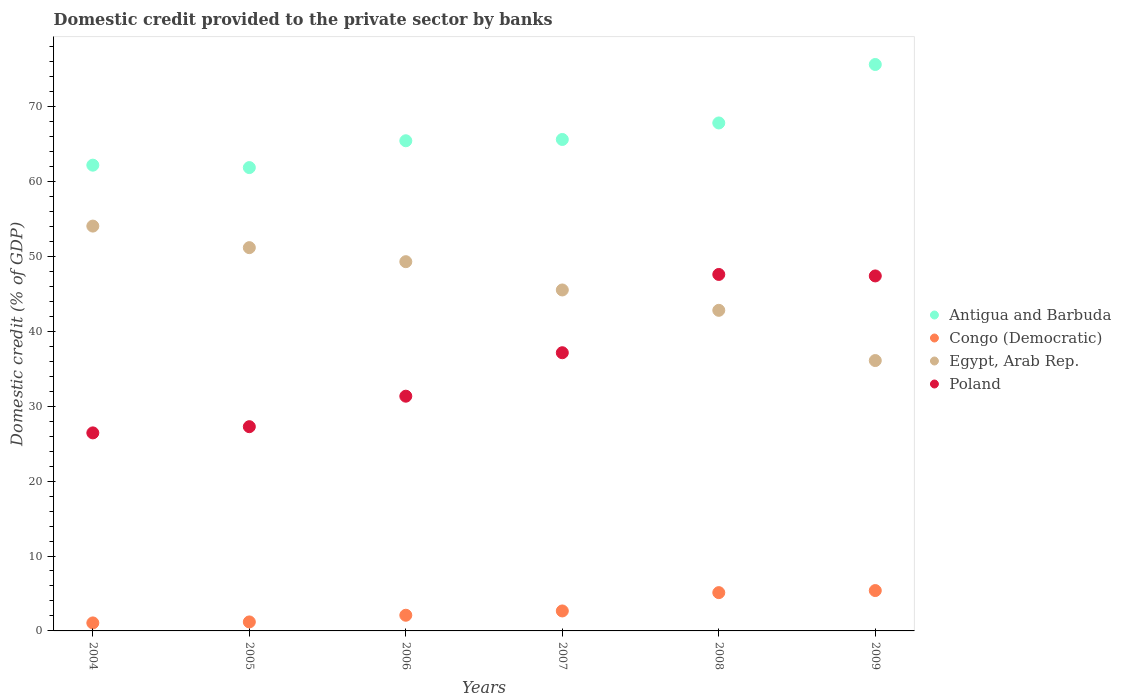How many different coloured dotlines are there?
Your answer should be compact. 4. What is the domestic credit provided to the private sector by banks in Congo (Democratic) in 2004?
Provide a succinct answer. 1.07. Across all years, what is the maximum domestic credit provided to the private sector by banks in Congo (Democratic)?
Offer a terse response. 5.39. Across all years, what is the minimum domestic credit provided to the private sector by banks in Congo (Democratic)?
Ensure brevity in your answer.  1.07. What is the total domestic credit provided to the private sector by banks in Poland in the graph?
Make the answer very short. 217.15. What is the difference between the domestic credit provided to the private sector by banks in Poland in 2005 and that in 2006?
Give a very brief answer. -4.07. What is the difference between the domestic credit provided to the private sector by banks in Antigua and Barbuda in 2006 and the domestic credit provided to the private sector by banks in Poland in 2004?
Ensure brevity in your answer.  39. What is the average domestic credit provided to the private sector by banks in Congo (Democratic) per year?
Offer a terse response. 2.92. In the year 2008, what is the difference between the domestic credit provided to the private sector by banks in Congo (Democratic) and domestic credit provided to the private sector by banks in Poland?
Ensure brevity in your answer.  -42.47. In how many years, is the domestic credit provided to the private sector by banks in Egypt, Arab Rep. greater than 4 %?
Provide a short and direct response. 6. What is the ratio of the domestic credit provided to the private sector by banks in Poland in 2006 to that in 2008?
Your answer should be compact. 0.66. Is the domestic credit provided to the private sector by banks in Antigua and Barbuda in 2006 less than that in 2009?
Offer a terse response. Yes. Is the difference between the domestic credit provided to the private sector by banks in Congo (Democratic) in 2005 and 2009 greater than the difference between the domestic credit provided to the private sector by banks in Poland in 2005 and 2009?
Give a very brief answer. Yes. What is the difference between the highest and the second highest domestic credit provided to the private sector by banks in Antigua and Barbuda?
Keep it short and to the point. 7.8. What is the difference between the highest and the lowest domestic credit provided to the private sector by banks in Congo (Democratic)?
Make the answer very short. 4.32. Is the sum of the domestic credit provided to the private sector by banks in Egypt, Arab Rep. in 2004 and 2007 greater than the maximum domestic credit provided to the private sector by banks in Poland across all years?
Make the answer very short. Yes. Is it the case that in every year, the sum of the domestic credit provided to the private sector by banks in Egypt, Arab Rep. and domestic credit provided to the private sector by banks in Poland  is greater than the sum of domestic credit provided to the private sector by banks in Antigua and Barbuda and domestic credit provided to the private sector by banks in Congo (Democratic)?
Ensure brevity in your answer.  Yes. Is it the case that in every year, the sum of the domestic credit provided to the private sector by banks in Congo (Democratic) and domestic credit provided to the private sector by banks in Egypt, Arab Rep.  is greater than the domestic credit provided to the private sector by banks in Poland?
Your response must be concise. No. Are the values on the major ticks of Y-axis written in scientific E-notation?
Offer a very short reply. No. Does the graph contain any zero values?
Your response must be concise. No. Does the graph contain grids?
Keep it short and to the point. No. How many legend labels are there?
Make the answer very short. 4. What is the title of the graph?
Your answer should be compact. Domestic credit provided to the private sector by banks. Does "Antigua and Barbuda" appear as one of the legend labels in the graph?
Give a very brief answer. Yes. What is the label or title of the Y-axis?
Provide a short and direct response. Domestic credit (% of GDP). What is the Domestic credit (% of GDP) of Antigua and Barbuda in 2004?
Your response must be concise. 62.18. What is the Domestic credit (% of GDP) of Congo (Democratic) in 2004?
Ensure brevity in your answer.  1.07. What is the Domestic credit (% of GDP) of Egypt, Arab Rep. in 2004?
Keep it short and to the point. 54.04. What is the Domestic credit (% of GDP) of Poland in 2004?
Your response must be concise. 26.44. What is the Domestic credit (% of GDP) in Antigua and Barbuda in 2005?
Your answer should be very brief. 61.85. What is the Domestic credit (% of GDP) in Congo (Democratic) in 2005?
Give a very brief answer. 1.2. What is the Domestic credit (% of GDP) of Egypt, Arab Rep. in 2005?
Provide a succinct answer. 51.17. What is the Domestic credit (% of GDP) in Poland in 2005?
Give a very brief answer. 27.27. What is the Domestic credit (% of GDP) of Antigua and Barbuda in 2006?
Ensure brevity in your answer.  65.43. What is the Domestic credit (% of GDP) in Congo (Democratic) in 2006?
Provide a short and direct response. 2.09. What is the Domestic credit (% of GDP) in Egypt, Arab Rep. in 2006?
Give a very brief answer. 49.29. What is the Domestic credit (% of GDP) in Poland in 2006?
Your answer should be very brief. 31.33. What is the Domestic credit (% of GDP) in Antigua and Barbuda in 2007?
Keep it short and to the point. 65.61. What is the Domestic credit (% of GDP) in Congo (Democratic) in 2007?
Make the answer very short. 2.67. What is the Domestic credit (% of GDP) in Egypt, Arab Rep. in 2007?
Provide a succinct answer. 45.52. What is the Domestic credit (% of GDP) of Poland in 2007?
Make the answer very short. 37.14. What is the Domestic credit (% of GDP) in Antigua and Barbuda in 2008?
Your answer should be compact. 67.81. What is the Domestic credit (% of GDP) in Congo (Democratic) in 2008?
Ensure brevity in your answer.  5.11. What is the Domestic credit (% of GDP) in Egypt, Arab Rep. in 2008?
Make the answer very short. 42.8. What is the Domestic credit (% of GDP) of Poland in 2008?
Offer a terse response. 47.59. What is the Domestic credit (% of GDP) in Antigua and Barbuda in 2009?
Offer a terse response. 75.61. What is the Domestic credit (% of GDP) in Congo (Democratic) in 2009?
Provide a short and direct response. 5.39. What is the Domestic credit (% of GDP) in Egypt, Arab Rep. in 2009?
Ensure brevity in your answer.  36.09. What is the Domestic credit (% of GDP) of Poland in 2009?
Provide a succinct answer. 47.39. Across all years, what is the maximum Domestic credit (% of GDP) in Antigua and Barbuda?
Your answer should be compact. 75.61. Across all years, what is the maximum Domestic credit (% of GDP) in Congo (Democratic)?
Your answer should be compact. 5.39. Across all years, what is the maximum Domestic credit (% of GDP) of Egypt, Arab Rep.?
Provide a short and direct response. 54.04. Across all years, what is the maximum Domestic credit (% of GDP) in Poland?
Your response must be concise. 47.59. Across all years, what is the minimum Domestic credit (% of GDP) in Antigua and Barbuda?
Ensure brevity in your answer.  61.85. Across all years, what is the minimum Domestic credit (% of GDP) in Congo (Democratic)?
Give a very brief answer. 1.07. Across all years, what is the minimum Domestic credit (% of GDP) in Egypt, Arab Rep.?
Ensure brevity in your answer.  36.09. Across all years, what is the minimum Domestic credit (% of GDP) of Poland?
Offer a terse response. 26.44. What is the total Domestic credit (% of GDP) in Antigua and Barbuda in the graph?
Keep it short and to the point. 398.49. What is the total Domestic credit (% of GDP) of Congo (Democratic) in the graph?
Your answer should be compact. 17.53. What is the total Domestic credit (% of GDP) in Egypt, Arab Rep. in the graph?
Make the answer very short. 278.9. What is the total Domestic credit (% of GDP) of Poland in the graph?
Make the answer very short. 217.15. What is the difference between the Domestic credit (% of GDP) of Antigua and Barbuda in 2004 and that in 2005?
Give a very brief answer. 0.32. What is the difference between the Domestic credit (% of GDP) of Congo (Democratic) in 2004 and that in 2005?
Provide a short and direct response. -0.13. What is the difference between the Domestic credit (% of GDP) of Egypt, Arab Rep. in 2004 and that in 2005?
Your response must be concise. 2.88. What is the difference between the Domestic credit (% of GDP) of Poland in 2004 and that in 2005?
Ensure brevity in your answer.  -0.83. What is the difference between the Domestic credit (% of GDP) in Antigua and Barbuda in 2004 and that in 2006?
Offer a very short reply. -3.26. What is the difference between the Domestic credit (% of GDP) of Congo (Democratic) in 2004 and that in 2006?
Provide a short and direct response. -1.02. What is the difference between the Domestic credit (% of GDP) of Egypt, Arab Rep. in 2004 and that in 2006?
Give a very brief answer. 4.75. What is the difference between the Domestic credit (% of GDP) of Poland in 2004 and that in 2006?
Your response must be concise. -4.9. What is the difference between the Domestic credit (% of GDP) in Antigua and Barbuda in 2004 and that in 2007?
Ensure brevity in your answer.  -3.43. What is the difference between the Domestic credit (% of GDP) of Congo (Democratic) in 2004 and that in 2007?
Make the answer very short. -1.6. What is the difference between the Domestic credit (% of GDP) of Egypt, Arab Rep. in 2004 and that in 2007?
Your response must be concise. 8.53. What is the difference between the Domestic credit (% of GDP) in Poland in 2004 and that in 2007?
Offer a terse response. -10.7. What is the difference between the Domestic credit (% of GDP) of Antigua and Barbuda in 2004 and that in 2008?
Your response must be concise. -5.63. What is the difference between the Domestic credit (% of GDP) in Congo (Democratic) in 2004 and that in 2008?
Offer a terse response. -4.04. What is the difference between the Domestic credit (% of GDP) of Egypt, Arab Rep. in 2004 and that in 2008?
Provide a succinct answer. 11.25. What is the difference between the Domestic credit (% of GDP) of Poland in 2004 and that in 2008?
Offer a terse response. -21.15. What is the difference between the Domestic credit (% of GDP) of Antigua and Barbuda in 2004 and that in 2009?
Your answer should be very brief. -13.44. What is the difference between the Domestic credit (% of GDP) in Congo (Democratic) in 2004 and that in 2009?
Your answer should be compact. -4.32. What is the difference between the Domestic credit (% of GDP) in Egypt, Arab Rep. in 2004 and that in 2009?
Offer a terse response. 17.95. What is the difference between the Domestic credit (% of GDP) in Poland in 2004 and that in 2009?
Provide a succinct answer. -20.95. What is the difference between the Domestic credit (% of GDP) of Antigua and Barbuda in 2005 and that in 2006?
Your response must be concise. -3.58. What is the difference between the Domestic credit (% of GDP) of Congo (Democratic) in 2005 and that in 2006?
Offer a terse response. -0.89. What is the difference between the Domestic credit (% of GDP) of Egypt, Arab Rep. in 2005 and that in 2006?
Offer a very short reply. 1.87. What is the difference between the Domestic credit (% of GDP) of Poland in 2005 and that in 2006?
Provide a succinct answer. -4.07. What is the difference between the Domestic credit (% of GDP) in Antigua and Barbuda in 2005 and that in 2007?
Make the answer very short. -3.75. What is the difference between the Domestic credit (% of GDP) in Congo (Democratic) in 2005 and that in 2007?
Give a very brief answer. -1.46. What is the difference between the Domestic credit (% of GDP) of Egypt, Arab Rep. in 2005 and that in 2007?
Make the answer very short. 5.65. What is the difference between the Domestic credit (% of GDP) in Poland in 2005 and that in 2007?
Give a very brief answer. -9.87. What is the difference between the Domestic credit (% of GDP) in Antigua and Barbuda in 2005 and that in 2008?
Your answer should be very brief. -5.96. What is the difference between the Domestic credit (% of GDP) of Congo (Democratic) in 2005 and that in 2008?
Keep it short and to the point. -3.91. What is the difference between the Domestic credit (% of GDP) in Egypt, Arab Rep. in 2005 and that in 2008?
Provide a short and direct response. 8.37. What is the difference between the Domestic credit (% of GDP) in Poland in 2005 and that in 2008?
Offer a terse response. -20.32. What is the difference between the Domestic credit (% of GDP) of Antigua and Barbuda in 2005 and that in 2009?
Offer a very short reply. -13.76. What is the difference between the Domestic credit (% of GDP) in Congo (Democratic) in 2005 and that in 2009?
Provide a succinct answer. -4.19. What is the difference between the Domestic credit (% of GDP) of Egypt, Arab Rep. in 2005 and that in 2009?
Keep it short and to the point. 15.07. What is the difference between the Domestic credit (% of GDP) of Poland in 2005 and that in 2009?
Provide a succinct answer. -20.12. What is the difference between the Domestic credit (% of GDP) in Antigua and Barbuda in 2006 and that in 2007?
Your answer should be compact. -0.17. What is the difference between the Domestic credit (% of GDP) of Congo (Democratic) in 2006 and that in 2007?
Ensure brevity in your answer.  -0.57. What is the difference between the Domestic credit (% of GDP) of Egypt, Arab Rep. in 2006 and that in 2007?
Offer a terse response. 3.78. What is the difference between the Domestic credit (% of GDP) of Poland in 2006 and that in 2007?
Give a very brief answer. -5.8. What is the difference between the Domestic credit (% of GDP) of Antigua and Barbuda in 2006 and that in 2008?
Your answer should be compact. -2.38. What is the difference between the Domestic credit (% of GDP) of Congo (Democratic) in 2006 and that in 2008?
Ensure brevity in your answer.  -3.02. What is the difference between the Domestic credit (% of GDP) of Egypt, Arab Rep. in 2006 and that in 2008?
Offer a terse response. 6.49. What is the difference between the Domestic credit (% of GDP) of Poland in 2006 and that in 2008?
Your answer should be compact. -16.25. What is the difference between the Domestic credit (% of GDP) of Antigua and Barbuda in 2006 and that in 2009?
Keep it short and to the point. -10.18. What is the difference between the Domestic credit (% of GDP) of Congo (Democratic) in 2006 and that in 2009?
Provide a short and direct response. -3.3. What is the difference between the Domestic credit (% of GDP) in Egypt, Arab Rep. in 2006 and that in 2009?
Make the answer very short. 13.2. What is the difference between the Domestic credit (% of GDP) of Poland in 2006 and that in 2009?
Your response must be concise. -16.05. What is the difference between the Domestic credit (% of GDP) in Antigua and Barbuda in 2007 and that in 2008?
Ensure brevity in your answer.  -2.2. What is the difference between the Domestic credit (% of GDP) of Congo (Democratic) in 2007 and that in 2008?
Make the answer very short. -2.45. What is the difference between the Domestic credit (% of GDP) of Egypt, Arab Rep. in 2007 and that in 2008?
Offer a terse response. 2.72. What is the difference between the Domestic credit (% of GDP) of Poland in 2007 and that in 2008?
Offer a terse response. -10.45. What is the difference between the Domestic credit (% of GDP) of Antigua and Barbuda in 2007 and that in 2009?
Offer a terse response. -10.01. What is the difference between the Domestic credit (% of GDP) in Congo (Democratic) in 2007 and that in 2009?
Ensure brevity in your answer.  -2.72. What is the difference between the Domestic credit (% of GDP) in Egypt, Arab Rep. in 2007 and that in 2009?
Offer a very short reply. 9.42. What is the difference between the Domestic credit (% of GDP) in Poland in 2007 and that in 2009?
Offer a very short reply. -10.25. What is the difference between the Domestic credit (% of GDP) in Antigua and Barbuda in 2008 and that in 2009?
Provide a short and direct response. -7.8. What is the difference between the Domestic credit (% of GDP) of Congo (Democratic) in 2008 and that in 2009?
Ensure brevity in your answer.  -0.28. What is the difference between the Domestic credit (% of GDP) in Egypt, Arab Rep. in 2008 and that in 2009?
Provide a succinct answer. 6.7. What is the difference between the Domestic credit (% of GDP) of Poland in 2008 and that in 2009?
Offer a very short reply. 0.2. What is the difference between the Domestic credit (% of GDP) in Antigua and Barbuda in 2004 and the Domestic credit (% of GDP) in Congo (Democratic) in 2005?
Keep it short and to the point. 60.97. What is the difference between the Domestic credit (% of GDP) in Antigua and Barbuda in 2004 and the Domestic credit (% of GDP) in Egypt, Arab Rep. in 2005?
Give a very brief answer. 11.01. What is the difference between the Domestic credit (% of GDP) in Antigua and Barbuda in 2004 and the Domestic credit (% of GDP) in Poland in 2005?
Keep it short and to the point. 34.91. What is the difference between the Domestic credit (% of GDP) in Congo (Democratic) in 2004 and the Domestic credit (% of GDP) in Egypt, Arab Rep. in 2005?
Give a very brief answer. -50.1. What is the difference between the Domestic credit (% of GDP) in Congo (Democratic) in 2004 and the Domestic credit (% of GDP) in Poland in 2005?
Ensure brevity in your answer.  -26.2. What is the difference between the Domestic credit (% of GDP) in Egypt, Arab Rep. in 2004 and the Domestic credit (% of GDP) in Poland in 2005?
Your answer should be very brief. 26.78. What is the difference between the Domestic credit (% of GDP) in Antigua and Barbuda in 2004 and the Domestic credit (% of GDP) in Congo (Democratic) in 2006?
Your response must be concise. 60.08. What is the difference between the Domestic credit (% of GDP) in Antigua and Barbuda in 2004 and the Domestic credit (% of GDP) in Egypt, Arab Rep. in 2006?
Your answer should be compact. 12.88. What is the difference between the Domestic credit (% of GDP) in Antigua and Barbuda in 2004 and the Domestic credit (% of GDP) in Poland in 2006?
Offer a terse response. 30.84. What is the difference between the Domestic credit (% of GDP) of Congo (Democratic) in 2004 and the Domestic credit (% of GDP) of Egypt, Arab Rep. in 2006?
Keep it short and to the point. -48.22. What is the difference between the Domestic credit (% of GDP) in Congo (Democratic) in 2004 and the Domestic credit (% of GDP) in Poland in 2006?
Your answer should be very brief. -30.27. What is the difference between the Domestic credit (% of GDP) in Egypt, Arab Rep. in 2004 and the Domestic credit (% of GDP) in Poland in 2006?
Keep it short and to the point. 22.71. What is the difference between the Domestic credit (% of GDP) in Antigua and Barbuda in 2004 and the Domestic credit (% of GDP) in Congo (Democratic) in 2007?
Provide a short and direct response. 59.51. What is the difference between the Domestic credit (% of GDP) of Antigua and Barbuda in 2004 and the Domestic credit (% of GDP) of Egypt, Arab Rep. in 2007?
Your response must be concise. 16.66. What is the difference between the Domestic credit (% of GDP) of Antigua and Barbuda in 2004 and the Domestic credit (% of GDP) of Poland in 2007?
Give a very brief answer. 25.04. What is the difference between the Domestic credit (% of GDP) of Congo (Democratic) in 2004 and the Domestic credit (% of GDP) of Egypt, Arab Rep. in 2007?
Give a very brief answer. -44.45. What is the difference between the Domestic credit (% of GDP) in Congo (Democratic) in 2004 and the Domestic credit (% of GDP) in Poland in 2007?
Your answer should be compact. -36.07. What is the difference between the Domestic credit (% of GDP) of Egypt, Arab Rep. in 2004 and the Domestic credit (% of GDP) of Poland in 2007?
Make the answer very short. 16.91. What is the difference between the Domestic credit (% of GDP) in Antigua and Barbuda in 2004 and the Domestic credit (% of GDP) in Congo (Democratic) in 2008?
Ensure brevity in your answer.  57.06. What is the difference between the Domestic credit (% of GDP) in Antigua and Barbuda in 2004 and the Domestic credit (% of GDP) in Egypt, Arab Rep. in 2008?
Your response must be concise. 19.38. What is the difference between the Domestic credit (% of GDP) of Antigua and Barbuda in 2004 and the Domestic credit (% of GDP) of Poland in 2008?
Your answer should be compact. 14.59. What is the difference between the Domestic credit (% of GDP) of Congo (Democratic) in 2004 and the Domestic credit (% of GDP) of Egypt, Arab Rep. in 2008?
Ensure brevity in your answer.  -41.73. What is the difference between the Domestic credit (% of GDP) of Congo (Democratic) in 2004 and the Domestic credit (% of GDP) of Poland in 2008?
Your response must be concise. -46.52. What is the difference between the Domestic credit (% of GDP) in Egypt, Arab Rep. in 2004 and the Domestic credit (% of GDP) in Poland in 2008?
Ensure brevity in your answer.  6.46. What is the difference between the Domestic credit (% of GDP) in Antigua and Barbuda in 2004 and the Domestic credit (% of GDP) in Congo (Democratic) in 2009?
Offer a terse response. 56.79. What is the difference between the Domestic credit (% of GDP) of Antigua and Barbuda in 2004 and the Domestic credit (% of GDP) of Egypt, Arab Rep. in 2009?
Offer a terse response. 26.08. What is the difference between the Domestic credit (% of GDP) of Antigua and Barbuda in 2004 and the Domestic credit (% of GDP) of Poland in 2009?
Your answer should be compact. 14.79. What is the difference between the Domestic credit (% of GDP) in Congo (Democratic) in 2004 and the Domestic credit (% of GDP) in Egypt, Arab Rep. in 2009?
Provide a succinct answer. -35.02. What is the difference between the Domestic credit (% of GDP) of Congo (Democratic) in 2004 and the Domestic credit (% of GDP) of Poland in 2009?
Your answer should be very brief. -46.32. What is the difference between the Domestic credit (% of GDP) in Egypt, Arab Rep. in 2004 and the Domestic credit (% of GDP) in Poland in 2009?
Keep it short and to the point. 6.65. What is the difference between the Domestic credit (% of GDP) of Antigua and Barbuda in 2005 and the Domestic credit (% of GDP) of Congo (Democratic) in 2006?
Your answer should be compact. 59.76. What is the difference between the Domestic credit (% of GDP) in Antigua and Barbuda in 2005 and the Domestic credit (% of GDP) in Egypt, Arab Rep. in 2006?
Keep it short and to the point. 12.56. What is the difference between the Domestic credit (% of GDP) in Antigua and Barbuda in 2005 and the Domestic credit (% of GDP) in Poland in 2006?
Your response must be concise. 30.52. What is the difference between the Domestic credit (% of GDP) in Congo (Democratic) in 2005 and the Domestic credit (% of GDP) in Egypt, Arab Rep. in 2006?
Provide a short and direct response. -48.09. What is the difference between the Domestic credit (% of GDP) in Congo (Democratic) in 2005 and the Domestic credit (% of GDP) in Poland in 2006?
Provide a short and direct response. -30.13. What is the difference between the Domestic credit (% of GDP) of Egypt, Arab Rep. in 2005 and the Domestic credit (% of GDP) of Poland in 2006?
Ensure brevity in your answer.  19.83. What is the difference between the Domestic credit (% of GDP) in Antigua and Barbuda in 2005 and the Domestic credit (% of GDP) in Congo (Democratic) in 2007?
Ensure brevity in your answer.  59.19. What is the difference between the Domestic credit (% of GDP) of Antigua and Barbuda in 2005 and the Domestic credit (% of GDP) of Egypt, Arab Rep. in 2007?
Offer a very short reply. 16.34. What is the difference between the Domestic credit (% of GDP) in Antigua and Barbuda in 2005 and the Domestic credit (% of GDP) in Poland in 2007?
Offer a terse response. 24.72. What is the difference between the Domestic credit (% of GDP) in Congo (Democratic) in 2005 and the Domestic credit (% of GDP) in Egypt, Arab Rep. in 2007?
Make the answer very short. -44.31. What is the difference between the Domestic credit (% of GDP) of Congo (Democratic) in 2005 and the Domestic credit (% of GDP) of Poland in 2007?
Your answer should be compact. -35.94. What is the difference between the Domestic credit (% of GDP) of Egypt, Arab Rep. in 2005 and the Domestic credit (% of GDP) of Poland in 2007?
Make the answer very short. 14.03. What is the difference between the Domestic credit (% of GDP) of Antigua and Barbuda in 2005 and the Domestic credit (% of GDP) of Congo (Democratic) in 2008?
Your answer should be compact. 56.74. What is the difference between the Domestic credit (% of GDP) in Antigua and Barbuda in 2005 and the Domestic credit (% of GDP) in Egypt, Arab Rep. in 2008?
Make the answer very short. 19.06. What is the difference between the Domestic credit (% of GDP) in Antigua and Barbuda in 2005 and the Domestic credit (% of GDP) in Poland in 2008?
Your answer should be compact. 14.27. What is the difference between the Domestic credit (% of GDP) of Congo (Democratic) in 2005 and the Domestic credit (% of GDP) of Egypt, Arab Rep. in 2008?
Offer a terse response. -41.6. What is the difference between the Domestic credit (% of GDP) of Congo (Democratic) in 2005 and the Domestic credit (% of GDP) of Poland in 2008?
Give a very brief answer. -46.39. What is the difference between the Domestic credit (% of GDP) of Egypt, Arab Rep. in 2005 and the Domestic credit (% of GDP) of Poland in 2008?
Offer a very short reply. 3.58. What is the difference between the Domestic credit (% of GDP) in Antigua and Barbuda in 2005 and the Domestic credit (% of GDP) in Congo (Democratic) in 2009?
Offer a terse response. 56.47. What is the difference between the Domestic credit (% of GDP) in Antigua and Barbuda in 2005 and the Domestic credit (% of GDP) in Egypt, Arab Rep. in 2009?
Provide a succinct answer. 25.76. What is the difference between the Domestic credit (% of GDP) of Antigua and Barbuda in 2005 and the Domestic credit (% of GDP) of Poland in 2009?
Keep it short and to the point. 14.46. What is the difference between the Domestic credit (% of GDP) of Congo (Democratic) in 2005 and the Domestic credit (% of GDP) of Egypt, Arab Rep. in 2009?
Your response must be concise. -34.89. What is the difference between the Domestic credit (% of GDP) of Congo (Democratic) in 2005 and the Domestic credit (% of GDP) of Poland in 2009?
Ensure brevity in your answer.  -46.19. What is the difference between the Domestic credit (% of GDP) in Egypt, Arab Rep. in 2005 and the Domestic credit (% of GDP) in Poland in 2009?
Make the answer very short. 3.78. What is the difference between the Domestic credit (% of GDP) of Antigua and Barbuda in 2006 and the Domestic credit (% of GDP) of Congo (Democratic) in 2007?
Offer a very short reply. 62.77. What is the difference between the Domestic credit (% of GDP) of Antigua and Barbuda in 2006 and the Domestic credit (% of GDP) of Egypt, Arab Rep. in 2007?
Provide a short and direct response. 19.92. What is the difference between the Domestic credit (% of GDP) in Antigua and Barbuda in 2006 and the Domestic credit (% of GDP) in Poland in 2007?
Your response must be concise. 28.3. What is the difference between the Domestic credit (% of GDP) of Congo (Democratic) in 2006 and the Domestic credit (% of GDP) of Egypt, Arab Rep. in 2007?
Ensure brevity in your answer.  -43.42. What is the difference between the Domestic credit (% of GDP) in Congo (Democratic) in 2006 and the Domestic credit (% of GDP) in Poland in 2007?
Give a very brief answer. -35.05. What is the difference between the Domestic credit (% of GDP) in Egypt, Arab Rep. in 2006 and the Domestic credit (% of GDP) in Poland in 2007?
Your answer should be compact. 12.15. What is the difference between the Domestic credit (% of GDP) in Antigua and Barbuda in 2006 and the Domestic credit (% of GDP) in Congo (Democratic) in 2008?
Make the answer very short. 60.32. What is the difference between the Domestic credit (% of GDP) of Antigua and Barbuda in 2006 and the Domestic credit (% of GDP) of Egypt, Arab Rep. in 2008?
Provide a short and direct response. 22.64. What is the difference between the Domestic credit (% of GDP) of Antigua and Barbuda in 2006 and the Domestic credit (% of GDP) of Poland in 2008?
Provide a succinct answer. 17.85. What is the difference between the Domestic credit (% of GDP) of Congo (Democratic) in 2006 and the Domestic credit (% of GDP) of Egypt, Arab Rep. in 2008?
Give a very brief answer. -40.71. What is the difference between the Domestic credit (% of GDP) of Congo (Democratic) in 2006 and the Domestic credit (% of GDP) of Poland in 2008?
Your answer should be compact. -45.49. What is the difference between the Domestic credit (% of GDP) in Egypt, Arab Rep. in 2006 and the Domestic credit (% of GDP) in Poland in 2008?
Give a very brief answer. 1.7. What is the difference between the Domestic credit (% of GDP) of Antigua and Barbuda in 2006 and the Domestic credit (% of GDP) of Congo (Democratic) in 2009?
Your answer should be very brief. 60.05. What is the difference between the Domestic credit (% of GDP) in Antigua and Barbuda in 2006 and the Domestic credit (% of GDP) in Egypt, Arab Rep. in 2009?
Your answer should be very brief. 29.34. What is the difference between the Domestic credit (% of GDP) of Antigua and Barbuda in 2006 and the Domestic credit (% of GDP) of Poland in 2009?
Give a very brief answer. 18.05. What is the difference between the Domestic credit (% of GDP) in Congo (Democratic) in 2006 and the Domestic credit (% of GDP) in Egypt, Arab Rep. in 2009?
Keep it short and to the point. -34. What is the difference between the Domestic credit (% of GDP) of Congo (Democratic) in 2006 and the Domestic credit (% of GDP) of Poland in 2009?
Provide a succinct answer. -45.3. What is the difference between the Domestic credit (% of GDP) in Egypt, Arab Rep. in 2006 and the Domestic credit (% of GDP) in Poland in 2009?
Provide a short and direct response. 1.9. What is the difference between the Domestic credit (% of GDP) of Antigua and Barbuda in 2007 and the Domestic credit (% of GDP) of Congo (Democratic) in 2008?
Keep it short and to the point. 60.49. What is the difference between the Domestic credit (% of GDP) of Antigua and Barbuda in 2007 and the Domestic credit (% of GDP) of Egypt, Arab Rep. in 2008?
Ensure brevity in your answer.  22.81. What is the difference between the Domestic credit (% of GDP) of Antigua and Barbuda in 2007 and the Domestic credit (% of GDP) of Poland in 2008?
Your answer should be compact. 18.02. What is the difference between the Domestic credit (% of GDP) of Congo (Democratic) in 2007 and the Domestic credit (% of GDP) of Egypt, Arab Rep. in 2008?
Your answer should be very brief. -40.13. What is the difference between the Domestic credit (% of GDP) in Congo (Democratic) in 2007 and the Domestic credit (% of GDP) in Poland in 2008?
Your answer should be compact. -44.92. What is the difference between the Domestic credit (% of GDP) in Egypt, Arab Rep. in 2007 and the Domestic credit (% of GDP) in Poland in 2008?
Ensure brevity in your answer.  -2.07. What is the difference between the Domestic credit (% of GDP) in Antigua and Barbuda in 2007 and the Domestic credit (% of GDP) in Congo (Democratic) in 2009?
Ensure brevity in your answer.  60.22. What is the difference between the Domestic credit (% of GDP) of Antigua and Barbuda in 2007 and the Domestic credit (% of GDP) of Egypt, Arab Rep. in 2009?
Provide a short and direct response. 29.51. What is the difference between the Domestic credit (% of GDP) of Antigua and Barbuda in 2007 and the Domestic credit (% of GDP) of Poland in 2009?
Your answer should be compact. 18.22. What is the difference between the Domestic credit (% of GDP) in Congo (Democratic) in 2007 and the Domestic credit (% of GDP) in Egypt, Arab Rep. in 2009?
Offer a very short reply. -33.43. What is the difference between the Domestic credit (% of GDP) of Congo (Democratic) in 2007 and the Domestic credit (% of GDP) of Poland in 2009?
Offer a very short reply. -44.72. What is the difference between the Domestic credit (% of GDP) in Egypt, Arab Rep. in 2007 and the Domestic credit (% of GDP) in Poland in 2009?
Make the answer very short. -1.87. What is the difference between the Domestic credit (% of GDP) of Antigua and Barbuda in 2008 and the Domestic credit (% of GDP) of Congo (Democratic) in 2009?
Give a very brief answer. 62.42. What is the difference between the Domestic credit (% of GDP) of Antigua and Barbuda in 2008 and the Domestic credit (% of GDP) of Egypt, Arab Rep. in 2009?
Your answer should be compact. 31.72. What is the difference between the Domestic credit (% of GDP) of Antigua and Barbuda in 2008 and the Domestic credit (% of GDP) of Poland in 2009?
Make the answer very short. 20.42. What is the difference between the Domestic credit (% of GDP) in Congo (Democratic) in 2008 and the Domestic credit (% of GDP) in Egypt, Arab Rep. in 2009?
Ensure brevity in your answer.  -30.98. What is the difference between the Domestic credit (% of GDP) in Congo (Democratic) in 2008 and the Domestic credit (% of GDP) in Poland in 2009?
Provide a short and direct response. -42.28. What is the difference between the Domestic credit (% of GDP) of Egypt, Arab Rep. in 2008 and the Domestic credit (% of GDP) of Poland in 2009?
Offer a very short reply. -4.59. What is the average Domestic credit (% of GDP) of Antigua and Barbuda per year?
Make the answer very short. 66.42. What is the average Domestic credit (% of GDP) in Congo (Democratic) per year?
Provide a succinct answer. 2.92. What is the average Domestic credit (% of GDP) of Egypt, Arab Rep. per year?
Ensure brevity in your answer.  46.48. What is the average Domestic credit (% of GDP) of Poland per year?
Your response must be concise. 36.19. In the year 2004, what is the difference between the Domestic credit (% of GDP) in Antigua and Barbuda and Domestic credit (% of GDP) in Congo (Democratic)?
Your answer should be compact. 61.11. In the year 2004, what is the difference between the Domestic credit (% of GDP) in Antigua and Barbuda and Domestic credit (% of GDP) in Egypt, Arab Rep.?
Provide a succinct answer. 8.13. In the year 2004, what is the difference between the Domestic credit (% of GDP) of Antigua and Barbuda and Domestic credit (% of GDP) of Poland?
Your answer should be very brief. 35.74. In the year 2004, what is the difference between the Domestic credit (% of GDP) of Congo (Democratic) and Domestic credit (% of GDP) of Egypt, Arab Rep.?
Offer a terse response. -52.97. In the year 2004, what is the difference between the Domestic credit (% of GDP) of Congo (Democratic) and Domestic credit (% of GDP) of Poland?
Provide a short and direct response. -25.37. In the year 2004, what is the difference between the Domestic credit (% of GDP) in Egypt, Arab Rep. and Domestic credit (% of GDP) in Poland?
Your answer should be compact. 27.61. In the year 2005, what is the difference between the Domestic credit (% of GDP) of Antigua and Barbuda and Domestic credit (% of GDP) of Congo (Democratic)?
Your answer should be very brief. 60.65. In the year 2005, what is the difference between the Domestic credit (% of GDP) of Antigua and Barbuda and Domestic credit (% of GDP) of Egypt, Arab Rep.?
Provide a succinct answer. 10.69. In the year 2005, what is the difference between the Domestic credit (% of GDP) of Antigua and Barbuda and Domestic credit (% of GDP) of Poland?
Provide a short and direct response. 34.59. In the year 2005, what is the difference between the Domestic credit (% of GDP) of Congo (Democratic) and Domestic credit (% of GDP) of Egypt, Arab Rep.?
Make the answer very short. -49.96. In the year 2005, what is the difference between the Domestic credit (% of GDP) in Congo (Democratic) and Domestic credit (% of GDP) in Poland?
Keep it short and to the point. -26.06. In the year 2005, what is the difference between the Domestic credit (% of GDP) of Egypt, Arab Rep. and Domestic credit (% of GDP) of Poland?
Give a very brief answer. 23.9. In the year 2006, what is the difference between the Domestic credit (% of GDP) of Antigua and Barbuda and Domestic credit (% of GDP) of Congo (Democratic)?
Make the answer very short. 63.34. In the year 2006, what is the difference between the Domestic credit (% of GDP) of Antigua and Barbuda and Domestic credit (% of GDP) of Egypt, Arab Rep.?
Ensure brevity in your answer.  16.14. In the year 2006, what is the difference between the Domestic credit (% of GDP) of Antigua and Barbuda and Domestic credit (% of GDP) of Poland?
Offer a terse response. 34.1. In the year 2006, what is the difference between the Domestic credit (% of GDP) in Congo (Democratic) and Domestic credit (% of GDP) in Egypt, Arab Rep.?
Your answer should be very brief. -47.2. In the year 2006, what is the difference between the Domestic credit (% of GDP) of Congo (Democratic) and Domestic credit (% of GDP) of Poland?
Your answer should be very brief. -29.24. In the year 2006, what is the difference between the Domestic credit (% of GDP) in Egypt, Arab Rep. and Domestic credit (% of GDP) in Poland?
Your response must be concise. 17.96. In the year 2007, what is the difference between the Domestic credit (% of GDP) in Antigua and Barbuda and Domestic credit (% of GDP) in Congo (Democratic)?
Offer a very short reply. 62.94. In the year 2007, what is the difference between the Domestic credit (% of GDP) of Antigua and Barbuda and Domestic credit (% of GDP) of Egypt, Arab Rep.?
Make the answer very short. 20.09. In the year 2007, what is the difference between the Domestic credit (% of GDP) in Antigua and Barbuda and Domestic credit (% of GDP) in Poland?
Your response must be concise. 28.47. In the year 2007, what is the difference between the Domestic credit (% of GDP) of Congo (Democratic) and Domestic credit (% of GDP) of Egypt, Arab Rep.?
Keep it short and to the point. -42.85. In the year 2007, what is the difference between the Domestic credit (% of GDP) in Congo (Democratic) and Domestic credit (% of GDP) in Poland?
Ensure brevity in your answer.  -34.47. In the year 2007, what is the difference between the Domestic credit (% of GDP) of Egypt, Arab Rep. and Domestic credit (% of GDP) of Poland?
Your response must be concise. 8.38. In the year 2008, what is the difference between the Domestic credit (% of GDP) of Antigua and Barbuda and Domestic credit (% of GDP) of Congo (Democratic)?
Make the answer very short. 62.7. In the year 2008, what is the difference between the Domestic credit (% of GDP) in Antigua and Barbuda and Domestic credit (% of GDP) in Egypt, Arab Rep.?
Give a very brief answer. 25.01. In the year 2008, what is the difference between the Domestic credit (% of GDP) of Antigua and Barbuda and Domestic credit (% of GDP) of Poland?
Your answer should be very brief. 20.22. In the year 2008, what is the difference between the Domestic credit (% of GDP) of Congo (Democratic) and Domestic credit (% of GDP) of Egypt, Arab Rep.?
Offer a very short reply. -37.69. In the year 2008, what is the difference between the Domestic credit (% of GDP) of Congo (Democratic) and Domestic credit (% of GDP) of Poland?
Your answer should be compact. -42.47. In the year 2008, what is the difference between the Domestic credit (% of GDP) in Egypt, Arab Rep. and Domestic credit (% of GDP) in Poland?
Your answer should be compact. -4.79. In the year 2009, what is the difference between the Domestic credit (% of GDP) of Antigua and Barbuda and Domestic credit (% of GDP) of Congo (Democratic)?
Provide a short and direct response. 70.23. In the year 2009, what is the difference between the Domestic credit (% of GDP) of Antigua and Barbuda and Domestic credit (% of GDP) of Egypt, Arab Rep.?
Make the answer very short. 39.52. In the year 2009, what is the difference between the Domestic credit (% of GDP) of Antigua and Barbuda and Domestic credit (% of GDP) of Poland?
Provide a succinct answer. 28.23. In the year 2009, what is the difference between the Domestic credit (% of GDP) of Congo (Democratic) and Domestic credit (% of GDP) of Egypt, Arab Rep.?
Make the answer very short. -30.7. In the year 2009, what is the difference between the Domestic credit (% of GDP) in Congo (Democratic) and Domestic credit (% of GDP) in Poland?
Provide a succinct answer. -42. In the year 2009, what is the difference between the Domestic credit (% of GDP) in Egypt, Arab Rep. and Domestic credit (% of GDP) in Poland?
Offer a very short reply. -11.3. What is the ratio of the Domestic credit (% of GDP) of Antigua and Barbuda in 2004 to that in 2005?
Your response must be concise. 1.01. What is the ratio of the Domestic credit (% of GDP) in Congo (Democratic) in 2004 to that in 2005?
Give a very brief answer. 0.89. What is the ratio of the Domestic credit (% of GDP) of Egypt, Arab Rep. in 2004 to that in 2005?
Offer a terse response. 1.06. What is the ratio of the Domestic credit (% of GDP) in Poland in 2004 to that in 2005?
Your response must be concise. 0.97. What is the ratio of the Domestic credit (% of GDP) in Antigua and Barbuda in 2004 to that in 2006?
Provide a succinct answer. 0.95. What is the ratio of the Domestic credit (% of GDP) of Congo (Democratic) in 2004 to that in 2006?
Your answer should be very brief. 0.51. What is the ratio of the Domestic credit (% of GDP) in Egypt, Arab Rep. in 2004 to that in 2006?
Ensure brevity in your answer.  1.1. What is the ratio of the Domestic credit (% of GDP) of Poland in 2004 to that in 2006?
Your response must be concise. 0.84. What is the ratio of the Domestic credit (% of GDP) of Antigua and Barbuda in 2004 to that in 2007?
Offer a terse response. 0.95. What is the ratio of the Domestic credit (% of GDP) of Congo (Democratic) in 2004 to that in 2007?
Offer a very short reply. 0.4. What is the ratio of the Domestic credit (% of GDP) of Egypt, Arab Rep. in 2004 to that in 2007?
Your answer should be compact. 1.19. What is the ratio of the Domestic credit (% of GDP) in Poland in 2004 to that in 2007?
Your response must be concise. 0.71. What is the ratio of the Domestic credit (% of GDP) of Antigua and Barbuda in 2004 to that in 2008?
Make the answer very short. 0.92. What is the ratio of the Domestic credit (% of GDP) of Congo (Democratic) in 2004 to that in 2008?
Offer a very short reply. 0.21. What is the ratio of the Domestic credit (% of GDP) in Egypt, Arab Rep. in 2004 to that in 2008?
Make the answer very short. 1.26. What is the ratio of the Domestic credit (% of GDP) of Poland in 2004 to that in 2008?
Keep it short and to the point. 0.56. What is the ratio of the Domestic credit (% of GDP) of Antigua and Barbuda in 2004 to that in 2009?
Ensure brevity in your answer.  0.82. What is the ratio of the Domestic credit (% of GDP) of Congo (Democratic) in 2004 to that in 2009?
Offer a terse response. 0.2. What is the ratio of the Domestic credit (% of GDP) in Egypt, Arab Rep. in 2004 to that in 2009?
Provide a short and direct response. 1.5. What is the ratio of the Domestic credit (% of GDP) of Poland in 2004 to that in 2009?
Make the answer very short. 0.56. What is the ratio of the Domestic credit (% of GDP) in Antigua and Barbuda in 2005 to that in 2006?
Your response must be concise. 0.95. What is the ratio of the Domestic credit (% of GDP) of Congo (Democratic) in 2005 to that in 2006?
Your answer should be compact. 0.57. What is the ratio of the Domestic credit (% of GDP) in Egypt, Arab Rep. in 2005 to that in 2006?
Give a very brief answer. 1.04. What is the ratio of the Domestic credit (% of GDP) of Poland in 2005 to that in 2006?
Give a very brief answer. 0.87. What is the ratio of the Domestic credit (% of GDP) of Antigua and Barbuda in 2005 to that in 2007?
Give a very brief answer. 0.94. What is the ratio of the Domestic credit (% of GDP) of Congo (Democratic) in 2005 to that in 2007?
Keep it short and to the point. 0.45. What is the ratio of the Domestic credit (% of GDP) in Egypt, Arab Rep. in 2005 to that in 2007?
Offer a terse response. 1.12. What is the ratio of the Domestic credit (% of GDP) of Poland in 2005 to that in 2007?
Make the answer very short. 0.73. What is the ratio of the Domestic credit (% of GDP) in Antigua and Barbuda in 2005 to that in 2008?
Your answer should be very brief. 0.91. What is the ratio of the Domestic credit (% of GDP) of Congo (Democratic) in 2005 to that in 2008?
Offer a terse response. 0.23. What is the ratio of the Domestic credit (% of GDP) in Egypt, Arab Rep. in 2005 to that in 2008?
Your answer should be compact. 1.2. What is the ratio of the Domestic credit (% of GDP) of Poland in 2005 to that in 2008?
Offer a very short reply. 0.57. What is the ratio of the Domestic credit (% of GDP) in Antigua and Barbuda in 2005 to that in 2009?
Ensure brevity in your answer.  0.82. What is the ratio of the Domestic credit (% of GDP) in Congo (Democratic) in 2005 to that in 2009?
Your response must be concise. 0.22. What is the ratio of the Domestic credit (% of GDP) of Egypt, Arab Rep. in 2005 to that in 2009?
Provide a short and direct response. 1.42. What is the ratio of the Domestic credit (% of GDP) of Poland in 2005 to that in 2009?
Your answer should be compact. 0.58. What is the ratio of the Domestic credit (% of GDP) of Congo (Democratic) in 2006 to that in 2007?
Your answer should be very brief. 0.78. What is the ratio of the Domestic credit (% of GDP) of Egypt, Arab Rep. in 2006 to that in 2007?
Provide a succinct answer. 1.08. What is the ratio of the Domestic credit (% of GDP) in Poland in 2006 to that in 2007?
Offer a terse response. 0.84. What is the ratio of the Domestic credit (% of GDP) of Antigua and Barbuda in 2006 to that in 2008?
Offer a terse response. 0.96. What is the ratio of the Domestic credit (% of GDP) of Congo (Democratic) in 2006 to that in 2008?
Provide a succinct answer. 0.41. What is the ratio of the Domestic credit (% of GDP) in Egypt, Arab Rep. in 2006 to that in 2008?
Give a very brief answer. 1.15. What is the ratio of the Domestic credit (% of GDP) of Poland in 2006 to that in 2008?
Offer a very short reply. 0.66. What is the ratio of the Domestic credit (% of GDP) in Antigua and Barbuda in 2006 to that in 2009?
Your response must be concise. 0.87. What is the ratio of the Domestic credit (% of GDP) in Congo (Democratic) in 2006 to that in 2009?
Keep it short and to the point. 0.39. What is the ratio of the Domestic credit (% of GDP) in Egypt, Arab Rep. in 2006 to that in 2009?
Keep it short and to the point. 1.37. What is the ratio of the Domestic credit (% of GDP) in Poland in 2006 to that in 2009?
Your response must be concise. 0.66. What is the ratio of the Domestic credit (% of GDP) in Antigua and Barbuda in 2007 to that in 2008?
Provide a succinct answer. 0.97. What is the ratio of the Domestic credit (% of GDP) in Congo (Democratic) in 2007 to that in 2008?
Provide a succinct answer. 0.52. What is the ratio of the Domestic credit (% of GDP) of Egypt, Arab Rep. in 2007 to that in 2008?
Make the answer very short. 1.06. What is the ratio of the Domestic credit (% of GDP) in Poland in 2007 to that in 2008?
Your response must be concise. 0.78. What is the ratio of the Domestic credit (% of GDP) in Antigua and Barbuda in 2007 to that in 2009?
Keep it short and to the point. 0.87. What is the ratio of the Domestic credit (% of GDP) of Congo (Democratic) in 2007 to that in 2009?
Ensure brevity in your answer.  0.49. What is the ratio of the Domestic credit (% of GDP) in Egypt, Arab Rep. in 2007 to that in 2009?
Provide a succinct answer. 1.26. What is the ratio of the Domestic credit (% of GDP) of Poland in 2007 to that in 2009?
Make the answer very short. 0.78. What is the ratio of the Domestic credit (% of GDP) in Antigua and Barbuda in 2008 to that in 2009?
Your answer should be very brief. 0.9. What is the ratio of the Domestic credit (% of GDP) of Congo (Democratic) in 2008 to that in 2009?
Provide a succinct answer. 0.95. What is the ratio of the Domestic credit (% of GDP) in Egypt, Arab Rep. in 2008 to that in 2009?
Provide a short and direct response. 1.19. What is the ratio of the Domestic credit (% of GDP) in Poland in 2008 to that in 2009?
Give a very brief answer. 1. What is the difference between the highest and the second highest Domestic credit (% of GDP) of Antigua and Barbuda?
Keep it short and to the point. 7.8. What is the difference between the highest and the second highest Domestic credit (% of GDP) in Congo (Democratic)?
Give a very brief answer. 0.28. What is the difference between the highest and the second highest Domestic credit (% of GDP) in Egypt, Arab Rep.?
Your answer should be compact. 2.88. What is the difference between the highest and the second highest Domestic credit (% of GDP) in Poland?
Make the answer very short. 0.2. What is the difference between the highest and the lowest Domestic credit (% of GDP) of Antigua and Barbuda?
Give a very brief answer. 13.76. What is the difference between the highest and the lowest Domestic credit (% of GDP) of Congo (Democratic)?
Keep it short and to the point. 4.32. What is the difference between the highest and the lowest Domestic credit (% of GDP) in Egypt, Arab Rep.?
Ensure brevity in your answer.  17.95. What is the difference between the highest and the lowest Domestic credit (% of GDP) of Poland?
Offer a very short reply. 21.15. 